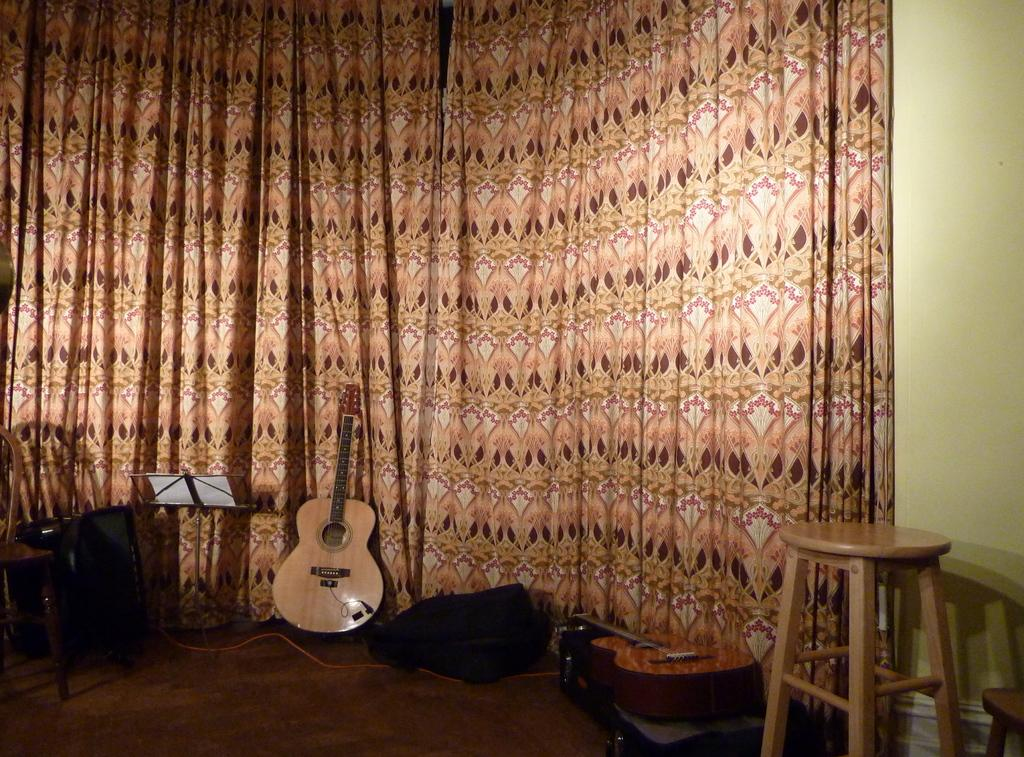What type of furniture is present in the image? There are stools in the image. What musical instruments can be seen in the image? There are guitars in the image. What is the book on in the image? There is a book on a musical book stand. Can you describe the objects in the image? There are some objects in the image, but their specific nature is not mentioned in the facts. What can be seen in the background of the image? There are curtains and a wall in the background of the image. Where is the toothbrush placed in the image? There is no toothbrush present in the image. What type of apparatus is used to play the guitars in the image? The facts do not mention any specific apparatus used to play the guitars in the image. 